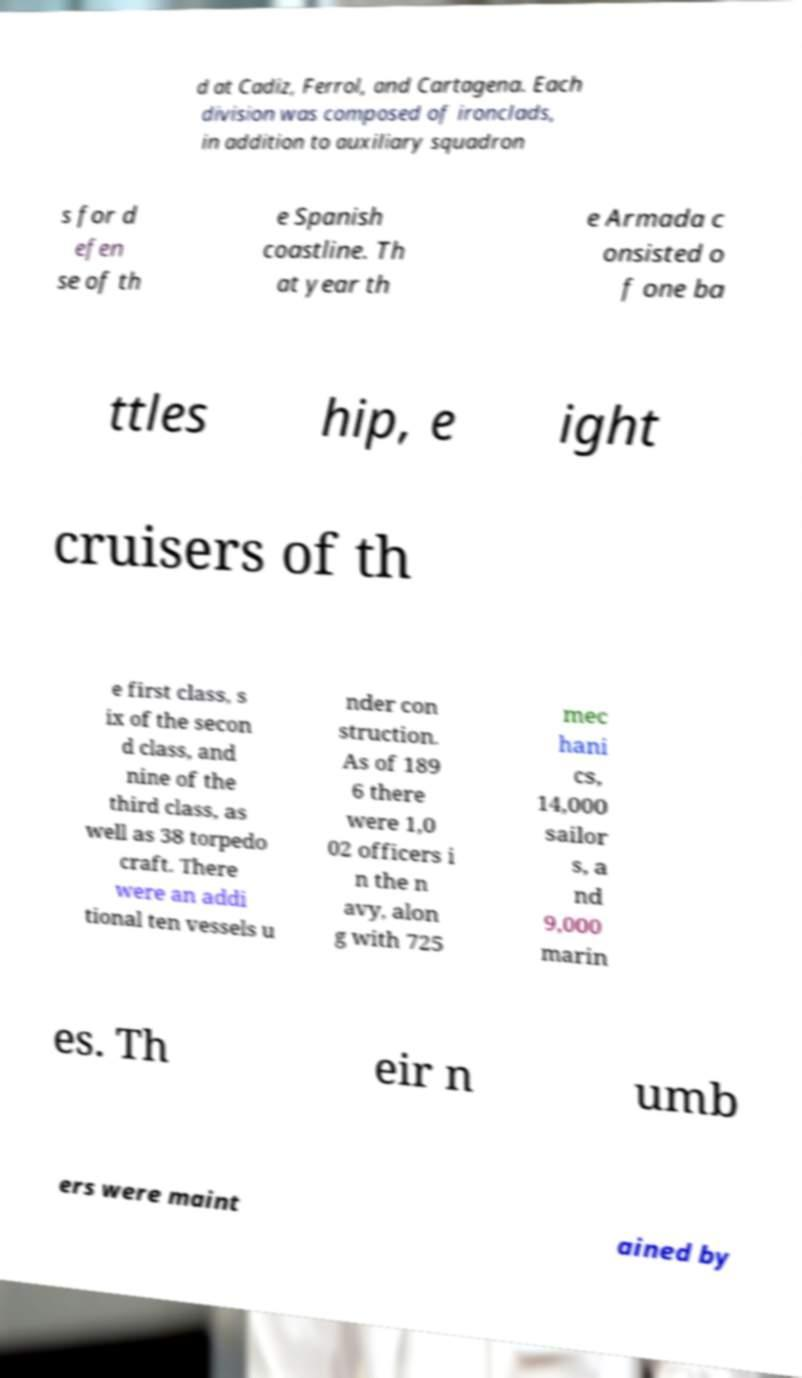I need the written content from this picture converted into text. Can you do that? d at Cadiz, Ferrol, and Cartagena. Each division was composed of ironclads, in addition to auxiliary squadron s for d efen se of th e Spanish coastline. Th at year th e Armada c onsisted o f one ba ttles hip, e ight cruisers of th e first class, s ix of the secon d class, and nine of the third class, as well as 38 torpedo craft. There were an addi tional ten vessels u nder con struction. As of 189 6 there were 1,0 02 officers i n the n avy, alon g with 725 mec hani cs, 14,000 sailor s, a nd 9,000 marin es. Th eir n umb ers were maint ained by 